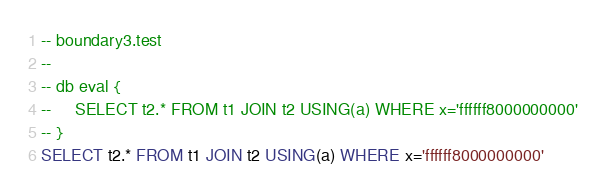Convert code to text. <code><loc_0><loc_0><loc_500><loc_500><_SQL_>-- boundary3.test
-- 
-- db eval {
--     SELECT t2.* FROM t1 JOIN t2 USING(a) WHERE x='ffffff8000000000'
-- }
SELECT t2.* FROM t1 JOIN t2 USING(a) WHERE x='ffffff8000000000'</code> 